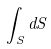Convert formula to latex. <formula><loc_0><loc_0><loc_500><loc_500>\int _ { S } d S</formula> 